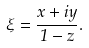<formula> <loc_0><loc_0><loc_500><loc_500>\xi = \frac { x + i y } { 1 - z } .</formula> 